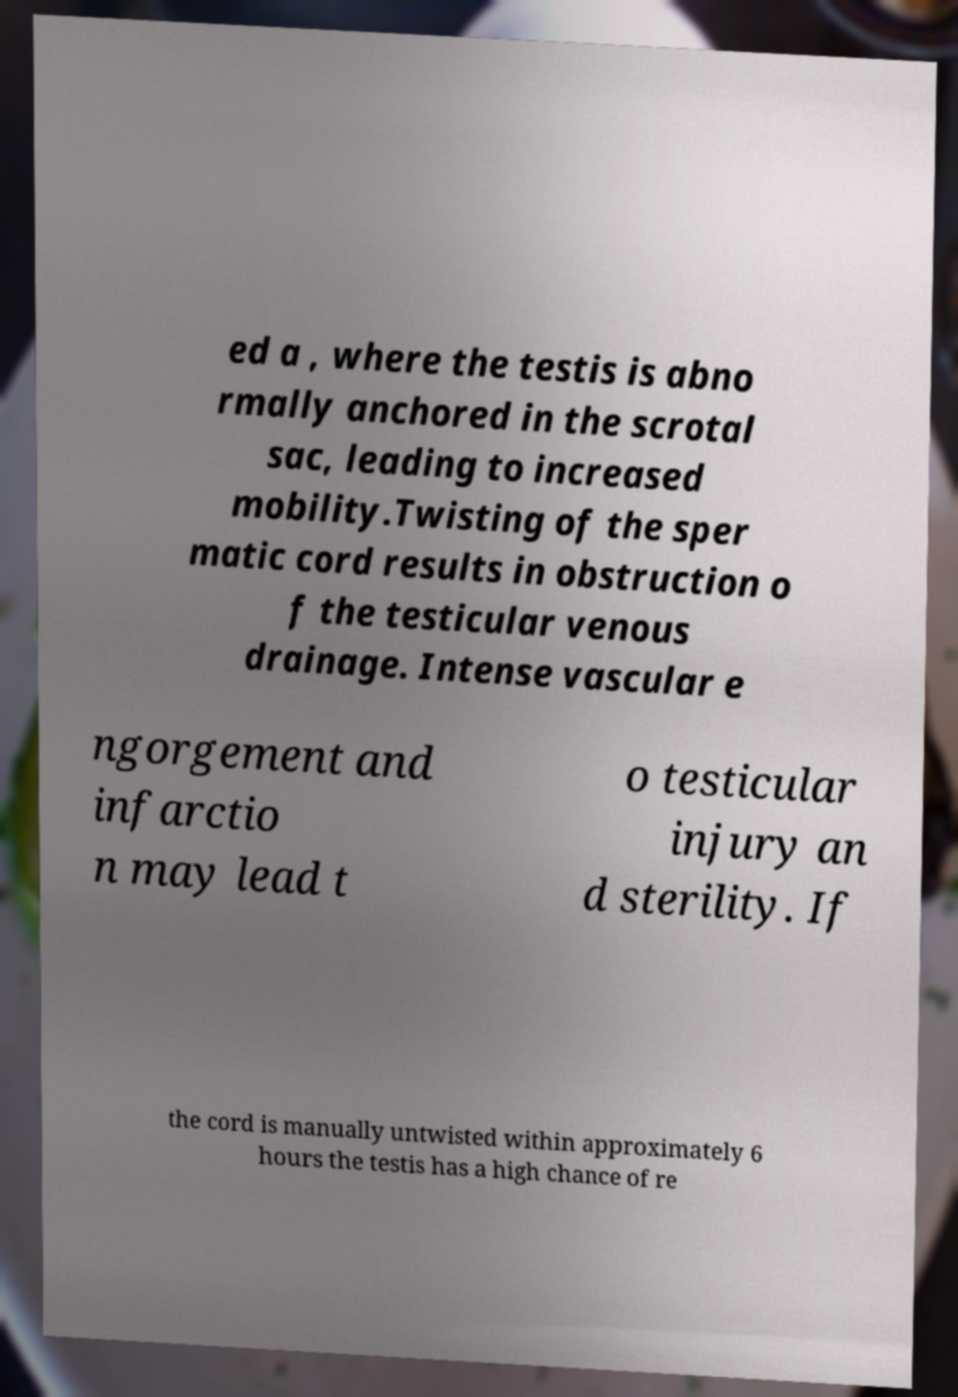Could you extract and type out the text from this image? ed a , where the testis is abno rmally anchored in the scrotal sac, leading to increased mobility.Twisting of the sper matic cord results in obstruction o f the testicular venous drainage. Intense vascular e ngorgement and infarctio n may lead t o testicular injury an d sterility. If the cord is manually untwisted within approximately 6 hours the testis has a high chance of re 